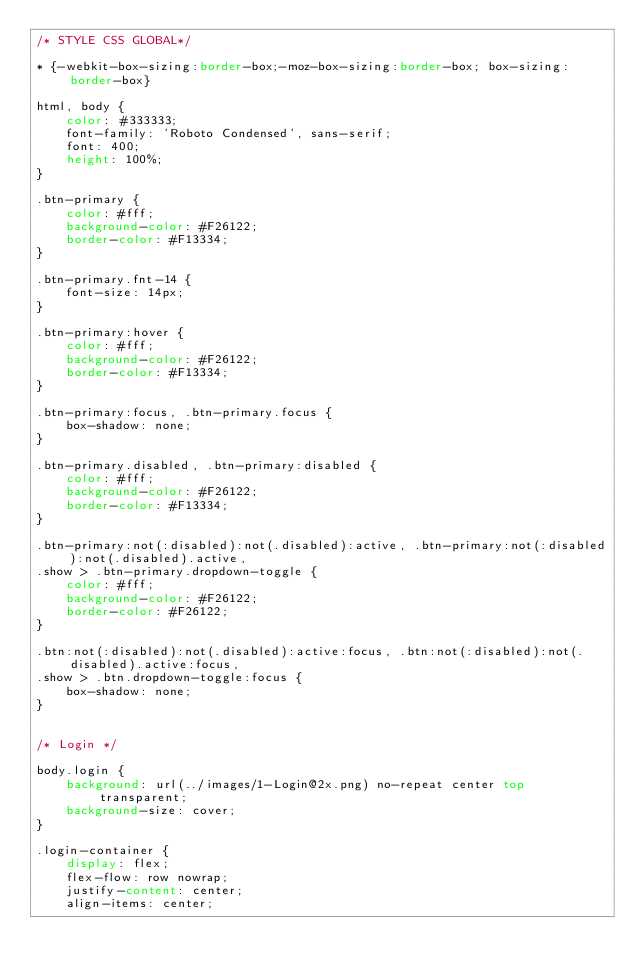<code> <loc_0><loc_0><loc_500><loc_500><_CSS_>/* STYLE CSS GLOBAL*/

* {-webkit-box-sizing:border-box;-moz-box-sizing:border-box; box-sizing:border-box}

html, body {
    color: #333333;
    font-family: 'Roboto Condensed', sans-serif;
    font: 400;
    height: 100%;
}

.btn-primary {
    color: #fff;
    background-color: #F26122;
    border-color: #F13334;
}

.btn-primary.fnt-14 {
    font-size: 14px;
}
  
.btn-primary:hover {
    color: #fff;
    background-color: #F26122;
    border-color: #F13334;
}
  
.btn-primary:focus, .btn-primary.focus {
    box-shadow: none;
}
  
.btn-primary.disabled, .btn-primary:disabled {
    color: #fff;
    background-color: #F26122;
    border-color: #F13334;
}
  
.btn-primary:not(:disabled):not(.disabled):active, .btn-primary:not(:disabled):not(.disabled).active,
.show > .btn-primary.dropdown-toggle {
    color: #fff;
    background-color: #F26122;
    border-color: #F26122;
}
  
.btn:not(:disabled):not(.disabled):active:focus, .btn:not(:disabled):not(.disabled).active:focus,
.show > .btn.dropdown-toggle:focus {
    box-shadow: none;
}


/* Login */

body.login {
    background: url(../images/1-Login@2x.png) no-repeat center top transparent;
    background-size: cover;
}

.login-container {
    display: flex;
    flex-flow: row nowrap;
    justify-content: center;
    align-items: center;</code> 